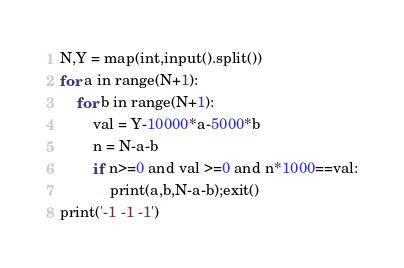Convert code to text. <code><loc_0><loc_0><loc_500><loc_500><_Python_>N,Y = map(int,input().split())
for a in range(N+1):
    for b in range(N+1):
        val = Y-10000*a-5000*b
        n = N-a-b
        if n>=0 and val >=0 and n*1000==val:
            print(a,b,N-a-b);exit()
print('-1 -1 -1')</code> 